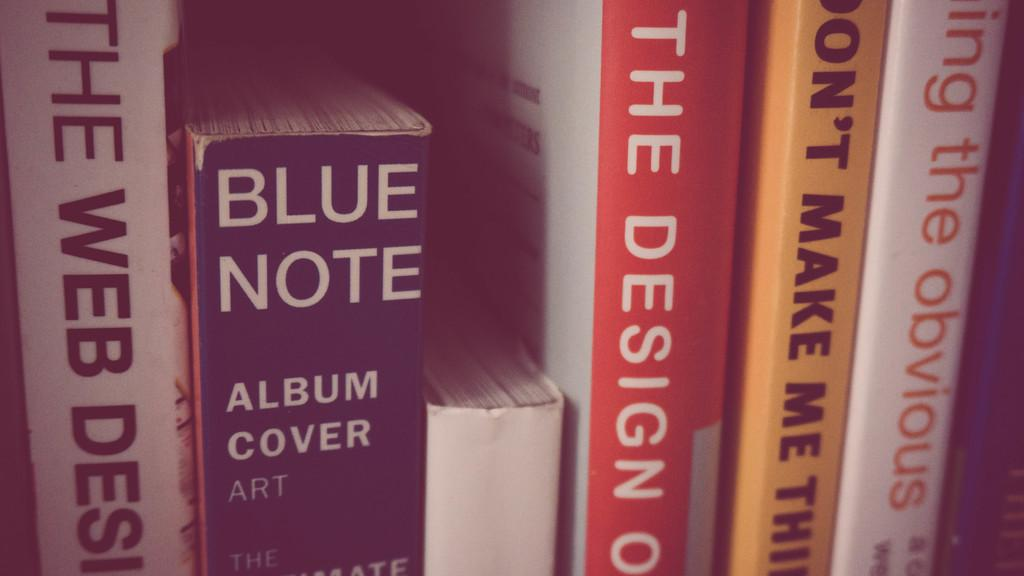<image>
Present a compact description of the photo's key features. several books, including Blue Note, are lined up as if on a shelf 